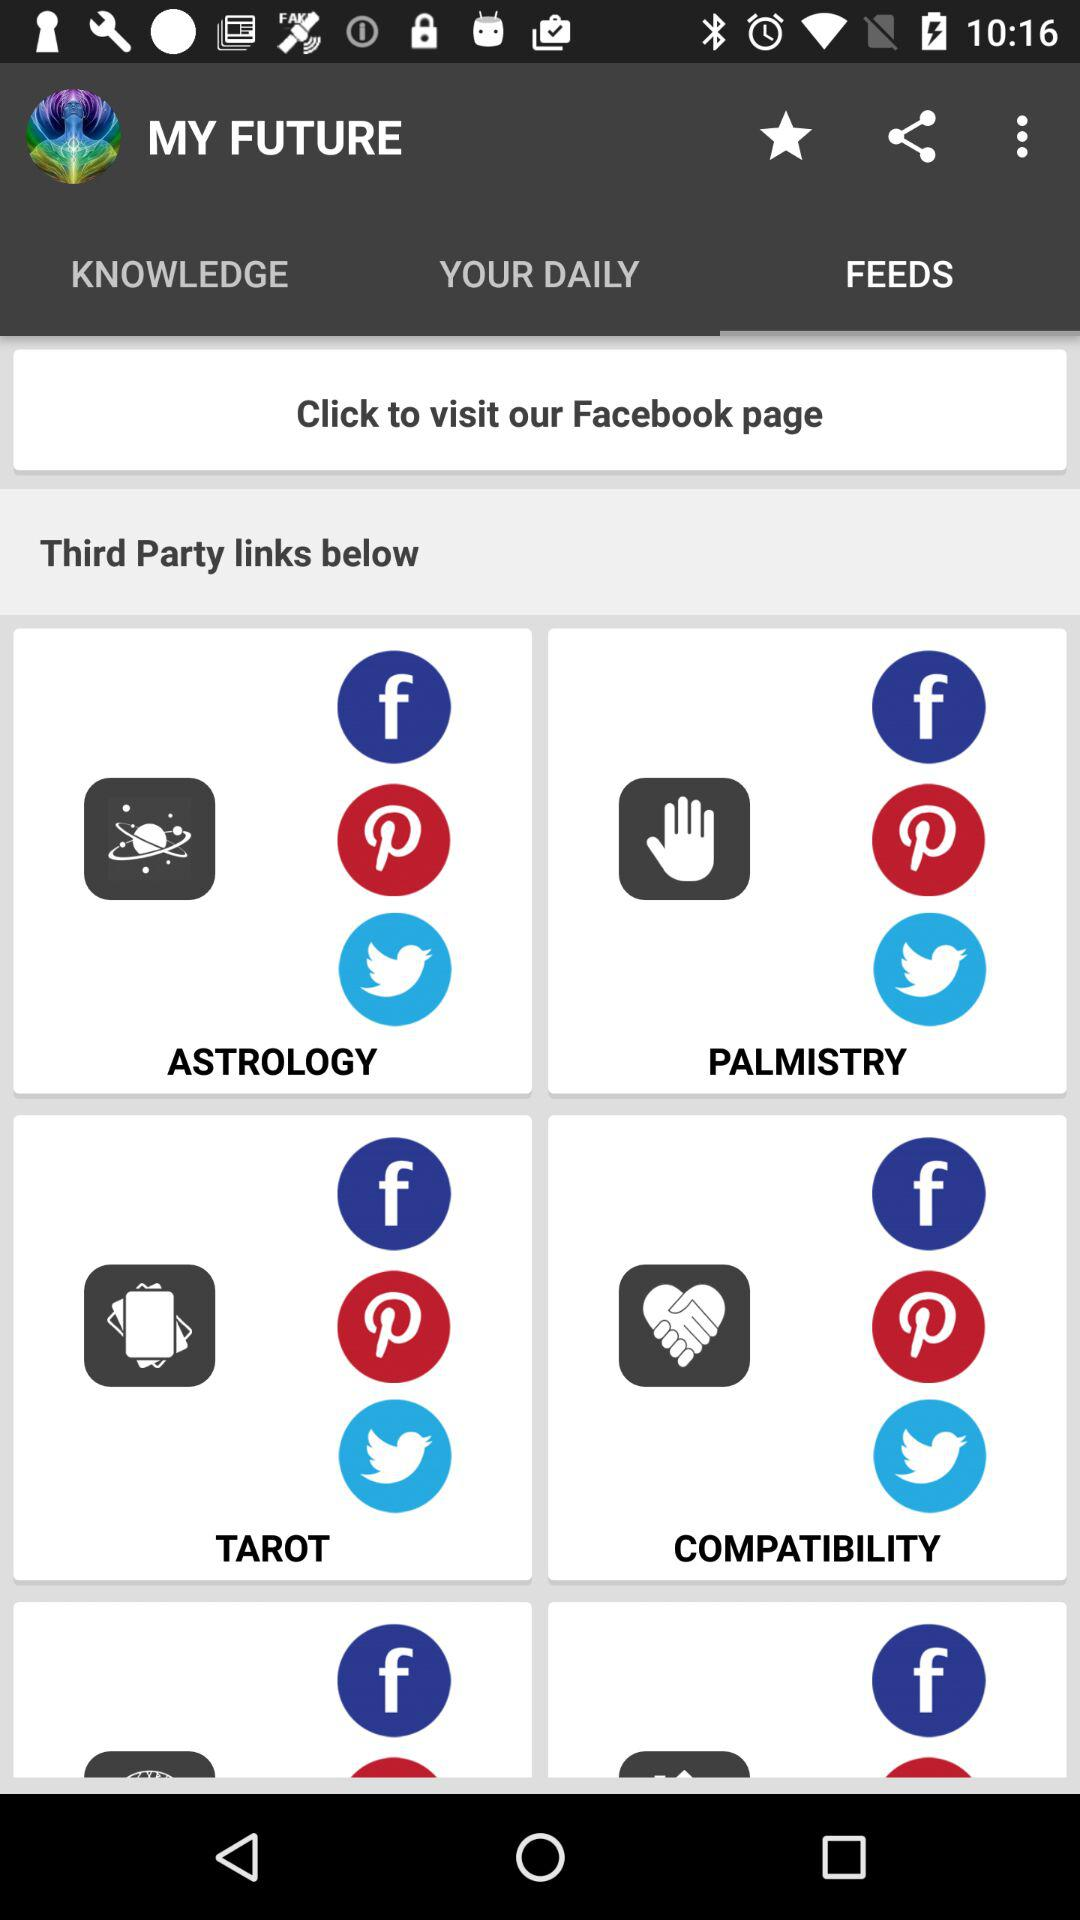What is the user's astrological sign?
When the provided information is insufficient, respond with <no answer>. <no answer> 